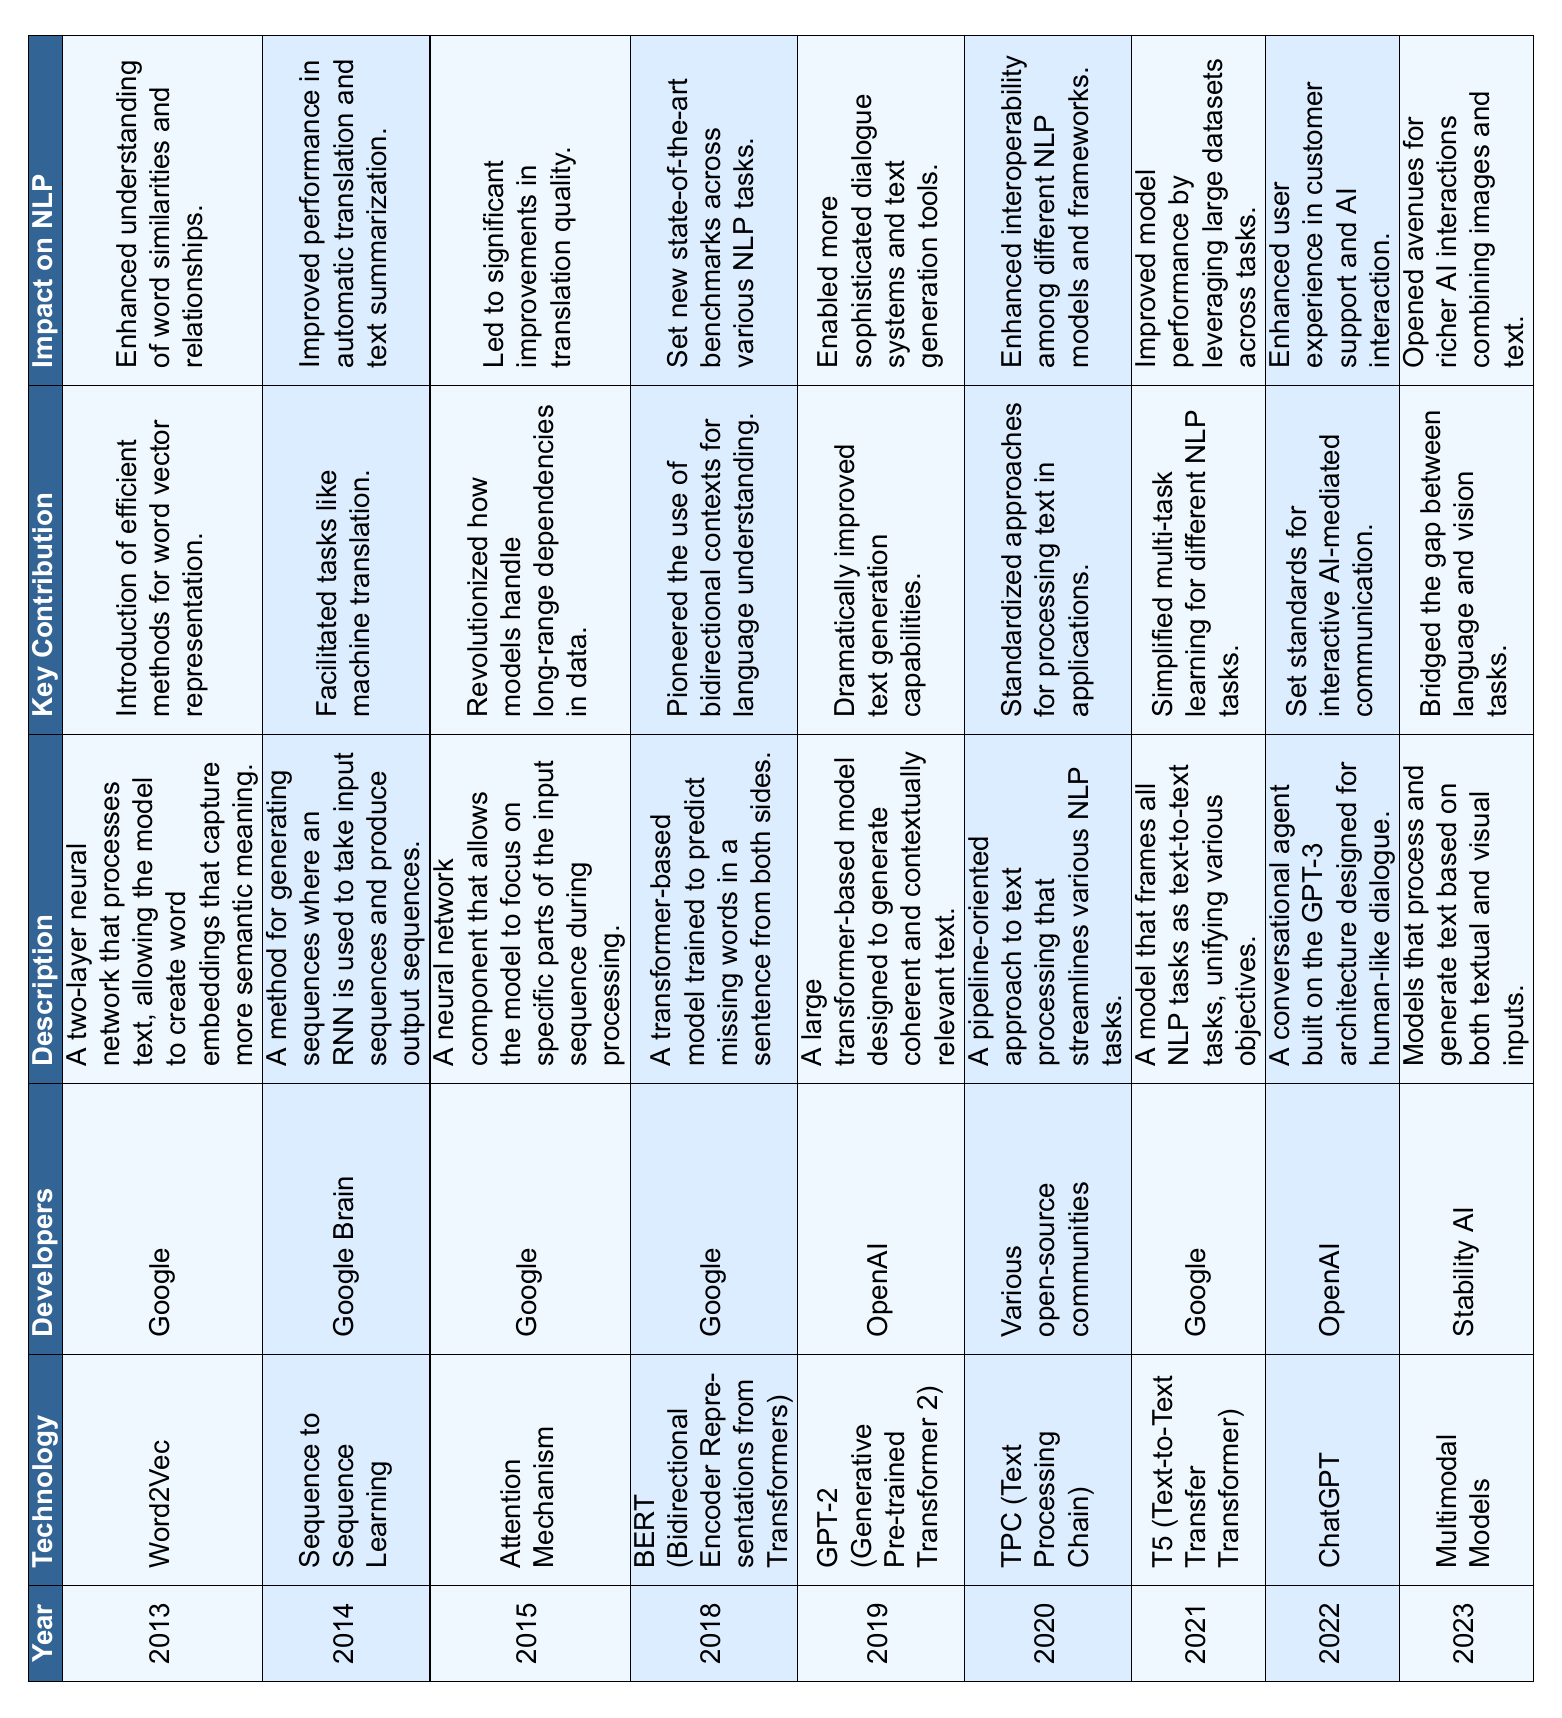What technological advancement was introduced in 2013? The table shows that the technological advancement introduced in 2013 is Word2Vec, developed by Google.
Answer: Word2Vec What is the developers' name for the technology introduced in 2022? The table indicates that the developers for the technology introduced in 2022, ChatGPT, are OpenAI.
Answer: OpenAI Which technology focused on bidirectional contexts for language understanding? From the table, the technology that pioneered the use of bidirectional contexts is BERT, introduced in 2018 by Google.
Answer: BERT What was the key contribution of the technology introduced in 2019? According to the table, the key contribution of GPT-2, introduced in 2019, was to dramatically improve text generation capabilities.
Answer: Dramatically improved text generation capabilities Which technology significantly enhanced interoperability among different NLP models and frameworks? The table notes that TPC (Text Processing Chain), introduced in 2020, enhanced interoperability among different NLP models and frameworks.
Answer: TPC (Text Processing Chain) What was the impact of the technology introduced in 2015? The table states that the impact of the Attention Mechanism, introduced in 2015, was to lead to significant improvements in translation quality.
Answer: Significant improvements in translation quality How many companies developed technologies listed in the table? By reviewing the developers' column, it can be seen that Google, Google Brain, OpenAI, and various open-source communities developed these technologies. This gives a total of 4 unique developers.
Answer: 4 What was the latest technology mentioned in the table? The last entry in the table, which corresponds to the most recent technology, is the Multimodal Models introduced in 2023.
Answer: Multimodal Models List the years when Google was involved as a developer. Examining the table reveals Google was involved as a developer in 2013 (Word2Vec), 2015 (Attention Mechanism), 2018 (BERT), and 2021 (T5), which totals to four years.
Answer: 2013, 2015, 2018, 2021 Which technology had a key contribution focused on multi-task learning? The table highlights that T5 (Text-to-Text Transfer Transformer) had a key contribution of simplifying multi-task learning for different NLP tasks.
Answer: T5 Did any technology introduced between 2014 and 2019 focus on machine translation? The table indicates that Sequence to Sequence Learning, introduced in 2014, facilitated tasks like machine translation, confirming the existence of a technology focused on machine translation in that timeframe.
Answer: Yes 